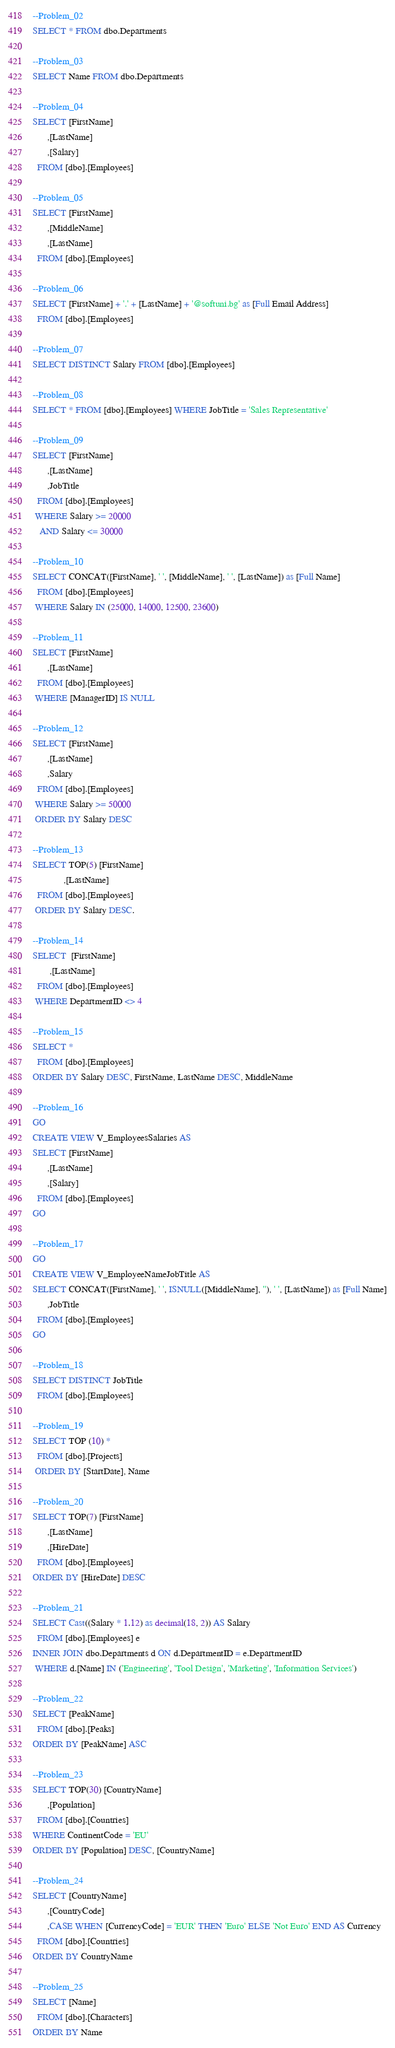Convert code to text. <code><loc_0><loc_0><loc_500><loc_500><_SQL_>--Problem_02
SELECT * FROM dbo.Departments

--Problem_03
SELECT Name FROM dbo.Departments

--Problem_04
SELECT [FirstName]
      ,[LastName]
      ,[Salary]      
  FROM [dbo].[Employees]

--Problem_05
SELECT [FirstName]
      ,[MiddleName]
      ,[LastName]  
  FROM [dbo].[Employees]
  
--Problem_06
SELECT [FirstName] + '.' + [LastName] + '@softuni.bg' as [Full Email Address]
  FROM [dbo].[Employees]

--Problem_07
SELECT DISTINCT Salary FROM [dbo].[Employees]

--Problem_08
SELECT * FROM [dbo].[Employees] WHERE JobTitle = 'Sales Representative'

--Problem_09
SELECT [FirstName]
      ,[LastName] 
	  ,JobTitle 
  FROM [dbo].[Employees] 
 WHERE Salary >= 20000
   AND Salary <= 30000

--Problem_10
SELECT CONCAT([FirstName], ' ', [MiddleName], ' ', [LastName]) as [Full Name]
  FROM [dbo].[Employees] 
 WHERE Salary IN (25000, 14000, 12500, 23600)

--Problem_11
SELECT [FirstName]
      ,[LastName]
  FROM [dbo].[Employees] 
 WHERE [ManagerID] IS NULL

--Problem_12
SELECT [FirstName]
      ,[LastName]
	  ,Salary
  FROM [dbo].[Employees] 
 WHERE Salary >= 50000
 ORDER BY Salary DESC

--Problem_13
SELECT TOP(5) [FirstName]
             ,[LastName]
  FROM [dbo].[Employees] 
 ORDER BY Salary DESC.

--Problem_14
SELECT  [FirstName]
       ,[LastName]
  FROM [dbo].[Employees] 
 WHERE DepartmentID <> 4
 
--Problem_15
SELECT *
  FROM [dbo].[Employees]
ORDER BY Salary DESC, FirstName, LastName DESC, MiddleName

--Problem_16
GO
CREATE VIEW V_EmployeesSalaries AS
SELECT [FirstName]
      ,[LastName]
      ,[Salary]      
  FROM [dbo].[Employees]
GO

--Problem_17
GO
CREATE VIEW V_EmployeeNameJobTitle AS
SELECT CONCAT([FirstName], ' ', ISNULL([MiddleName], ''), ' ', [LastName]) as [Full Name]
	  ,JobTitle
  FROM [dbo].[Employees] 
GO

--Problem_18
SELECT DISTINCT JobTitle
  FROM [dbo].[Employees] 
  
--Problem_19
SELECT TOP (10) *
  FROM [dbo].[Projects]
 ORDER BY [StartDate], Name

--Problem_20
SELECT TOP(7) [FirstName]
      ,[LastName]
      ,[HireDate]
  FROM [dbo].[Employees]
ORDER BY [HireDate] DESC

--Problem_21
SELECT Cast((Salary * 1.12) as decimal(18, 2)) AS Salary
  FROM [dbo].[Employees] e
INNER JOIN dbo.Departments d ON d.DepartmentID = e.DepartmentID
 WHERE d.[Name] IN ('Engineering', 'Tool Design', 'Marketing', 'Information Services') 

--Problem_22
SELECT [PeakName]      
  FROM [dbo].[Peaks]
ORDER BY [PeakName] ASC

--Problem_23
SELECT TOP(30) [CountryName]
      ,[Population]
  FROM [dbo].[Countries]
WHERE ContinentCode = 'EU'
ORDER BY [Population] DESC, [CountryName]

--Problem_24
SELECT [CountryName]
      ,[CountryCode]
	  ,CASE WHEN [CurrencyCode] = 'EUR' THEN 'Euro' ELSE 'Not Euro' END AS Currency
  FROM [dbo].[Countries]
ORDER BY CountryName 

--Problem_25
SELECT [Name]
  FROM [dbo].[Characters]
ORDER BY Name</code> 